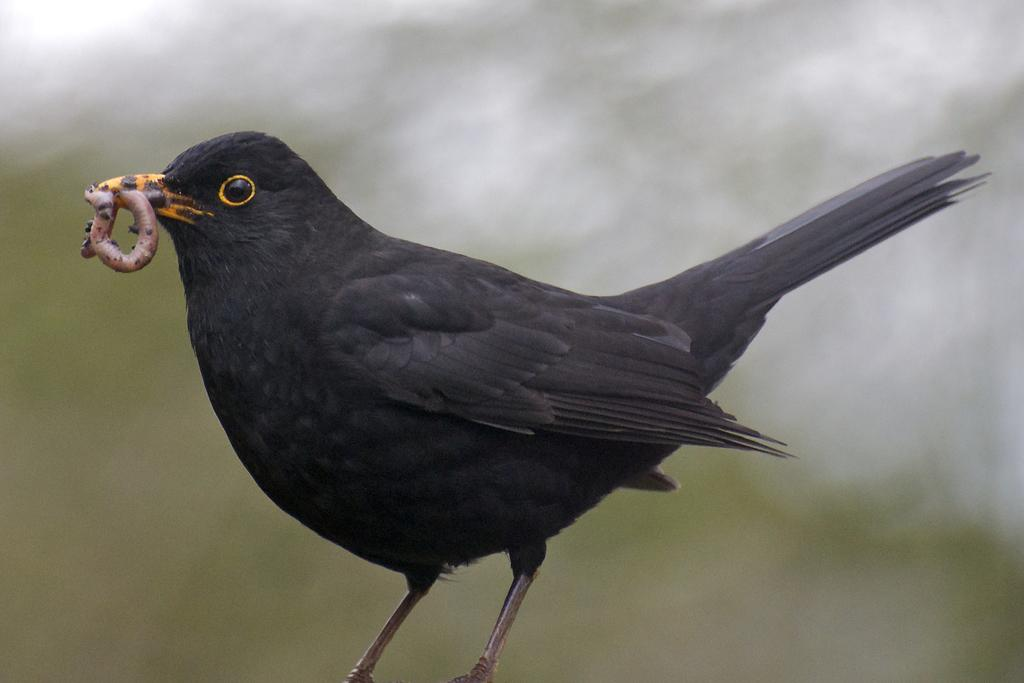What type of animal can be seen in the image? There is a bird in the image. What is the bird doing in the image? The bird is holding an insect in its mouth. Can you describe the background of the image? The background of the image is blurry. How does the bird expand its wings in the image? The bird does not expand its wings in the image; it is holding an insect in its mouth. 